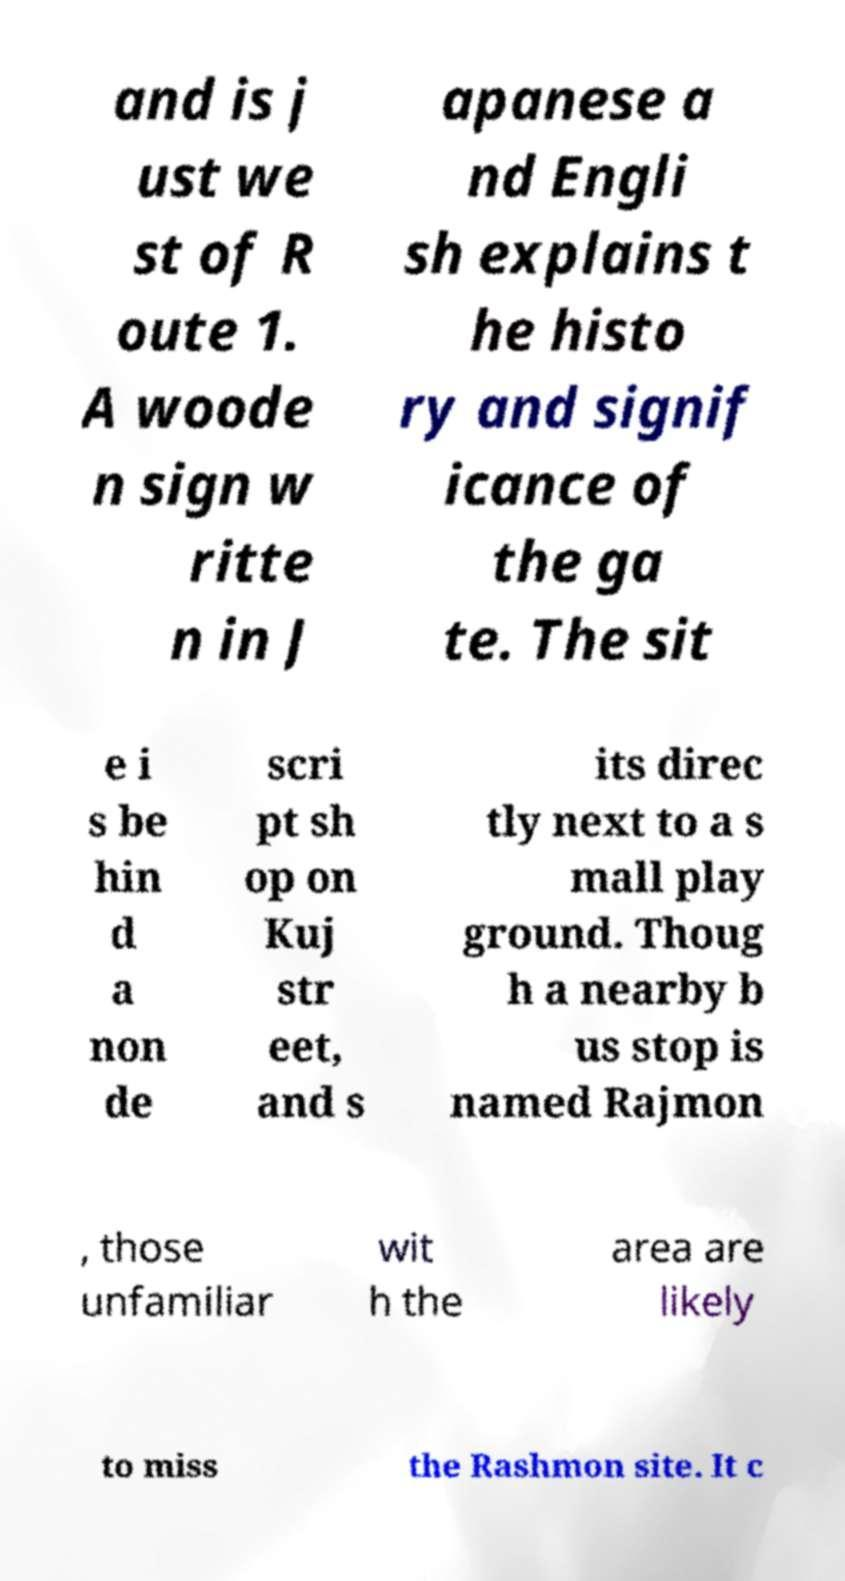Please read and relay the text visible in this image. What does it say? and is j ust we st of R oute 1. A woode n sign w ritte n in J apanese a nd Engli sh explains t he histo ry and signif icance of the ga te. The sit e i s be hin d a non de scri pt sh op on Kuj str eet, and s its direc tly next to a s mall play ground. Thoug h a nearby b us stop is named Rajmon , those unfamiliar wit h the area are likely to miss the Rashmon site. It c 